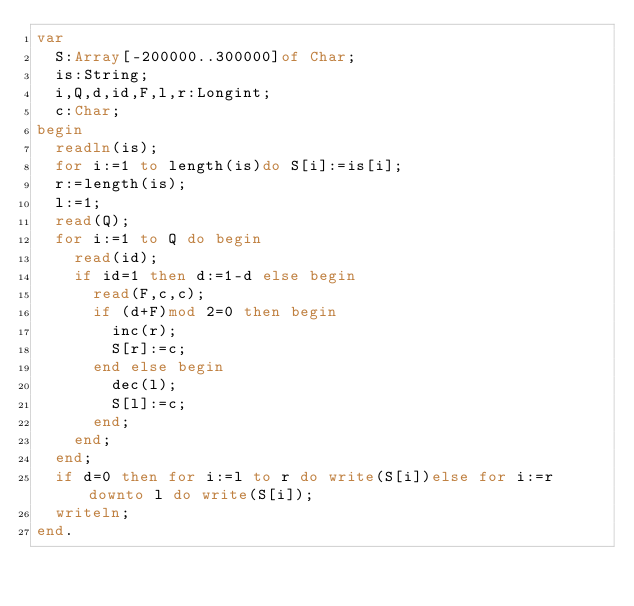<code> <loc_0><loc_0><loc_500><loc_500><_Pascal_>var
	S:Array[-200000..300000]of Char;
	is:String;
	i,Q,d,id,F,l,r:Longint;
	c:Char;
begin
	readln(is);
	for i:=1 to length(is)do S[i]:=is[i];
	r:=length(is);
	l:=1;
	read(Q);
	for i:=1 to Q do begin
		read(id);
		if id=1 then d:=1-d else begin
			read(F,c,c);
			if (d+F)mod 2=0 then begin
				inc(r);
				S[r]:=c;
			end else begin
				dec(l);
				S[l]:=c;
			end;
		end;
	end;
	if d=0 then for i:=l to r do write(S[i])else for i:=r downto l do write(S[i]);
	writeln;
end.
</code> 